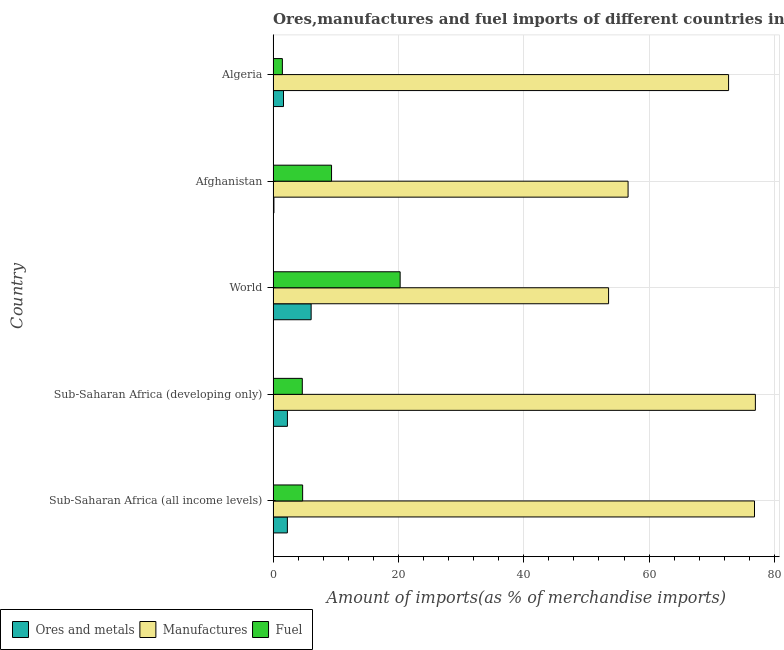How many different coloured bars are there?
Ensure brevity in your answer.  3. Are the number of bars per tick equal to the number of legend labels?
Ensure brevity in your answer.  Yes. Are the number of bars on each tick of the Y-axis equal?
Your answer should be compact. Yes. How many bars are there on the 3rd tick from the top?
Keep it short and to the point. 3. How many bars are there on the 1st tick from the bottom?
Your answer should be compact. 3. What is the label of the 2nd group of bars from the top?
Provide a succinct answer. Afghanistan. In how many cases, is the number of bars for a given country not equal to the number of legend labels?
Make the answer very short. 0. What is the percentage of ores and metals imports in Sub-Saharan Africa (developing only)?
Give a very brief answer. 2.28. Across all countries, what is the maximum percentage of ores and metals imports?
Give a very brief answer. 6.07. Across all countries, what is the minimum percentage of manufactures imports?
Provide a short and direct response. 53.54. In which country was the percentage of fuel imports minimum?
Keep it short and to the point. Algeria. What is the total percentage of manufactures imports in the graph?
Offer a very short reply. 336.67. What is the difference between the percentage of fuel imports in Sub-Saharan Africa (all income levels) and that in Sub-Saharan Africa (developing only)?
Ensure brevity in your answer.  0.05. What is the difference between the percentage of ores and metals imports in World and the percentage of fuel imports in Sub-Saharan Africa (developing only)?
Your answer should be compact. 1.41. What is the average percentage of manufactures imports per country?
Your answer should be compact. 67.33. What is the difference between the percentage of ores and metals imports and percentage of fuel imports in Sub-Saharan Africa (all income levels)?
Your response must be concise. -2.44. In how many countries, is the percentage of ores and metals imports greater than 28 %?
Give a very brief answer. 0. What is the ratio of the percentage of fuel imports in Sub-Saharan Africa (developing only) to that in World?
Your response must be concise. 0.23. Is the difference between the percentage of fuel imports in Algeria and Sub-Saharan Africa (developing only) greater than the difference between the percentage of ores and metals imports in Algeria and Sub-Saharan Africa (developing only)?
Provide a short and direct response. No. What is the difference between the highest and the second highest percentage of ores and metals imports?
Your response must be concise. 3.78. What is the difference between the highest and the lowest percentage of ores and metals imports?
Make the answer very short. 5.94. What does the 2nd bar from the top in Afghanistan represents?
Your answer should be very brief. Manufactures. What does the 1st bar from the bottom in Sub-Saharan Africa (developing only) represents?
Make the answer very short. Ores and metals. Are all the bars in the graph horizontal?
Your answer should be compact. Yes. What is the difference between two consecutive major ticks on the X-axis?
Keep it short and to the point. 20. How many legend labels are there?
Your answer should be very brief. 3. What is the title of the graph?
Offer a terse response. Ores,manufactures and fuel imports of different countries in 1974. What is the label or title of the X-axis?
Ensure brevity in your answer.  Amount of imports(as % of merchandise imports). What is the Amount of imports(as % of merchandise imports) in Ores and metals in Sub-Saharan Africa (all income levels)?
Give a very brief answer. 2.27. What is the Amount of imports(as % of merchandise imports) in Manufactures in Sub-Saharan Africa (all income levels)?
Your response must be concise. 76.83. What is the Amount of imports(as % of merchandise imports) in Fuel in Sub-Saharan Africa (all income levels)?
Make the answer very short. 4.71. What is the Amount of imports(as % of merchandise imports) in Ores and metals in Sub-Saharan Africa (developing only)?
Your response must be concise. 2.28. What is the Amount of imports(as % of merchandise imports) in Manufactures in Sub-Saharan Africa (developing only)?
Keep it short and to the point. 76.97. What is the Amount of imports(as % of merchandise imports) in Fuel in Sub-Saharan Africa (developing only)?
Provide a short and direct response. 4.66. What is the Amount of imports(as % of merchandise imports) of Ores and metals in World?
Give a very brief answer. 6.07. What is the Amount of imports(as % of merchandise imports) in Manufactures in World?
Give a very brief answer. 53.54. What is the Amount of imports(as % of merchandise imports) of Fuel in World?
Your response must be concise. 20.27. What is the Amount of imports(as % of merchandise imports) in Ores and metals in Afghanistan?
Provide a short and direct response. 0.13. What is the Amount of imports(as % of merchandise imports) in Manufactures in Afghanistan?
Make the answer very short. 56.65. What is the Amount of imports(as % of merchandise imports) in Fuel in Afghanistan?
Your response must be concise. 9.33. What is the Amount of imports(as % of merchandise imports) in Ores and metals in Algeria?
Offer a very short reply. 1.66. What is the Amount of imports(as % of merchandise imports) of Manufactures in Algeria?
Offer a very short reply. 72.69. What is the Amount of imports(as % of merchandise imports) of Fuel in Algeria?
Offer a very short reply. 1.48. Across all countries, what is the maximum Amount of imports(as % of merchandise imports) of Ores and metals?
Provide a succinct answer. 6.07. Across all countries, what is the maximum Amount of imports(as % of merchandise imports) in Manufactures?
Make the answer very short. 76.97. Across all countries, what is the maximum Amount of imports(as % of merchandise imports) of Fuel?
Your answer should be compact. 20.27. Across all countries, what is the minimum Amount of imports(as % of merchandise imports) in Ores and metals?
Your answer should be compact. 0.13. Across all countries, what is the minimum Amount of imports(as % of merchandise imports) of Manufactures?
Ensure brevity in your answer.  53.54. Across all countries, what is the minimum Amount of imports(as % of merchandise imports) in Fuel?
Offer a very short reply. 1.48. What is the total Amount of imports(as % of merchandise imports) in Ores and metals in the graph?
Provide a succinct answer. 12.41. What is the total Amount of imports(as % of merchandise imports) in Manufactures in the graph?
Provide a succinct answer. 336.67. What is the total Amount of imports(as % of merchandise imports) of Fuel in the graph?
Your answer should be compact. 40.44. What is the difference between the Amount of imports(as % of merchandise imports) of Ores and metals in Sub-Saharan Africa (all income levels) and that in Sub-Saharan Africa (developing only)?
Ensure brevity in your answer.  -0.01. What is the difference between the Amount of imports(as % of merchandise imports) in Manufactures in Sub-Saharan Africa (all income levels) and that in Sub-Saharan Africa (developing only)?
Your answer should be very brief. -0.14. What is the difference between the Amount of imports(as % of merchandise imports) of Fuel in Sub-Saharan Africa (all income levels) and that in Sub-Saharan Africa (developing only)?
Give a very brief answer. 0.05. What is the difference between the Amount of imports(as % of merchandise imports) of Ores and metals in Sub-Saharan Africa (all income levels) and that in World?
Offer a terse response. -3.79. What is the difference between the Amount of imports(as % of merchandise imports) in Manufactures in Sub-Saharan Africa (all income levels) and that in World?
Your answer should be very brief. 23.29. What is the difference between the Amount of imports(as % of merchandise imports) of Fuel in Sub-Saharan Africa (all income levels) and that in World?
Give a very brief answer. -15.56. What is the difference between the Amount of imports(as % of merchandise imports) of Ores and metals in Sub-Saharan Africa (all income levels) and that in Afghanistan?
Provide a short and direct response. 2.15. What is the difference between the Amount of imports(as % of merchandise imports) in Manufactures in Sub-Saharan Africa (all income levels) and that in Afghanistan?
Offer a very short reply. 20.18. What is the difference between the Amount of imports(as % of merchandise imports) in Fuel in Sub-Saharan Africa (all income levels) and that in Afghanistan?
Keep it short and to the point. -4.61. What is the difference between the Amount of imports(as % of merchandise imports) in Ores and metals in Sub-Saharan Africa (all income levels) and that in Algeria?
Your response must be concise. 0.62. What is the difference between the Amount of imports(as % of merchandise imports) of Manufactures in Sub-Saharan Africa (all income levels) and that in Algeria?
Provide a short and direct response. 4.14. What is the difference between the Amount of imports(as % of merchandise imports) of Fuel in Sub-Saharan Africa (all income levels) and that in Algeria?
Provide a succinct answer. 3.23. What is the difference between the Amount of imports(as % of merchandise imports) of Ores and metals in Sub-Saharan Africa (developing only) and that in World?
Your response must be concise. -3.78. What is the difference between the Amount of imports(as % of merchandise imports) of Manufactures in Sub-Saharan Africa (developing only) and that in World?
Ensure brevity in your answer.  23.43. What is the difference between the Amount of imports(as % of merchandise imports) of Fuel in Sub-Saharan Africa (developing only) and that in World?
Give a very brief answer. -15.61. What is the difference between the Amount of imports(as % of merchandise imports) of Ores and metals in Sub-Saharan Africa (developing only) and that in Afghanistan?
Keep it short and to the point. 2.16. What is the difference between the Amount of imports(as % of merchandise imports) of Manufactures in Sub-Saharan Africa (developing only) and that in Afghanistan?
Your answer should be compact. 20.32. What is the difference between the Amount of imports(as % of merchandise imports) in Fuel in Sub-Saharan Africa (developing only) and that in Afghanistan?
Keep it short and to the point. -4.67. What is the difference between the Amount of imports(as % of merchandise imports) in Ores and metals in Sub-Saharan Africa (developing only) and that in Algeria?
Provide a short and direct response. 0.63. What is the difference between the Amount of imports(as % of merchandise imports) of Manufactures in Sub-Saharan Africa (developing only) and that in Algeria?
Offer a terse response. 4.28. What is the difference between the Amount of imports(as % of merchandise imports) in Fuel in Sub-Saharan Africa (developing only) and that in Algeria?
Offer a very short reply. 3.18. What is the difference between the Amount of imports(as % of merchandise imports) in Ores and metals in World and that in Afghanistan?
Your response must be concise. 5.94. What is the difference between the Amount of imports(as % of merchandise imports) of Manufactures in World and that in Afghanistan?
Offer a very short reply. -3.11. What is the difference between the Amount of imports(as % of merchandise imports) in Fuel in World and that in Afghanistan?
Provide a short and direct response. 10.95. What is the difference between the Amount of imports(as % of merchandise imports) of Ores and metals in World and that in Algeria?
Ensure brevity in your answer.  4.41. What is the difference between the Amount of imports(as % of merchandise imports) in Manufactures in World and that in Algeria?
Provide a short and direct response. -19.15. What is the difference between the Amount of imports(as % of merchandise imports) in Fuel in World and that in Algeria?
Your answer should be compact. 18.79. What is the difference between the Amount of imports(as % of merchandise imports) in Ores and metals in Afghanistan and that in Algeria?
Offer a very short reply. -1.53. What is the difference between the Amount of imports(as % of merchandise imports) of Manufactures in Afghanistan and that in Algeria?
Provide a short and direct response. -16.04. What is the difference between the Amount of imports(as % of merchandise imports) of Fuel in Afghanistan and that in Algeria?
Provide a short and direct response. 7.85. What is the difference between the Amount of imports(as % of merchandise imports) in Ores and metals in Sub-Saharan Africa (all income levels) and the Amount of imports(as % of merchandise imports) in Manufactures in Sub-Saharan Africa (developing only)?
Your answer should be compact. -74.69. What is the difference between the Amount of imports(as % of merchandise imports) of Ores and metals in Sub-Saharan Africa (all income levels) and the Amount of imports(as % of merchandise imports) of Fuel in Sub-Saharan Africa (developing only)?
Ensure brevity in your answer.  -2.38. What is the difference between the Amount of imports(as % of merchandise imports) in Manufactures in Sub-Saharan Africa (all income levels) and the Amount of imports(as % of merchandise imports) in Fuel in Sub-Saharan Africa (developing only)?
Your answer should be very brief. 72.17. What is the difference between the Amount of imports(as % of merchandise imports) of Ores and metals in Sub-Saharan Africa (all income levels) and the Amount of imports(as % of merchandise imports) of Manufactures in World?
Give a very brief answer. -51.26. What is the difference between the Amount of imports(as % of merchandise imports) of Ores and metals in Sub-Saharan Africa (all income levels) and the Amount of imports(as % of merchandise imports) of Fuel in World?
Keep it short and to the point. -18. What is the difference between the Amount of imports(as % of merchandise imports) of Manufactures in Sub-Saharan Africa (all income levels) and the Amount of imports(as % of merchandise imports) of Fuel in World?
Offer a very short reply. 56.56. What is the difference between the Amount of imports(as % of merchandise imports) of Ores and metals in Sub-Saharan Africa (all income levels) and the Amount of imports(as % of merchandise imports) of Manufactures in Afghanistan?
Your response must be concise. -54.38. What is the difference between the Amount of imports(as % of merchandise imports) in Ores and metals in Sub-Saharan Africa (all income levels) and the Amount of imports(as % of merchandise imports) in Fuel in Afghanistan?
Your response must be concise. -7.05. What is the difference between the Amount of imports(as % of merchandise imports) in Manufactures in Sub-Saharan Africa (all income levels) and the Amount of imports(as % of merchandise imports) in Fuel in Afghanistan?
Make the answer very short. 67.5. What is the difference between the Amount of imports(as % of merchandise imports) of Ores and metals in Sub-Saharan Africa (all income levels) and the Amount of imports(as % of merchandise imports) of Manufactures in Algeria?
Your response must be concise. -70.42. What is the difference between the Amount of imports(as % of merchandise imports) of Ores and metals in Sub-Saharan Africa (all income levels) and the Amount of imports(as % of merchandise imports) of Fuel in Algeria?
Ensure brevity in your answer.  0.8. What is the difference between the Amount of imports(as % of merchandise imports) in Manufactures in Sub-Saharan Africa (all income levels) and the Amount of imports(as % of merchandise imports) in Fuel in Algeria?
Your answer should be compact. 75.35. What is the difference between the Amount of imports(as % of merchandise imports) of Ores and metals in Sub-Saharan Africa (developing only) and the Amount of imports(as % of merchandise imports) of Manufactures in World?
Your response must be concise. -51.25. What is the difference between the Amount of imports(as % of merchandise imports) of Ores and metals in Sub-Saharan Africa (developing only) and the Amount of imports(as % of merchandise imports) of Fuel in World?
Make the answer very short. -17.99. What is the difference between the Amount of imports(as % of merchandise imports) in Manufactures in Sub-Saharan Africa (developing only) and the Amount of imports(as % of merchandise imports) in Fuel in World?
Give a very brief answer. 56.7. What is the difference between the Amount of imports(as % of merchandise imports) in Ores and metals in Sub-Saharan Africa (developing only) and the Amount of imports(as % of merchandise imports) in Manufactures in Afghanistan?
Give a very brief answer. -54.37. What is the difference between the Amount of imports(as % of merchandise imports) in Ores and metals in Sub-Saharan Africa (developing only) and the Amount of imports(as % of merchandise imports) in Fuel in Afghanistan?
Provide a succinct answer. -7.04. What is the difference between the Amount of imports(as % of merchandise imports) of Manufactures in Sub-Saharan Africa (developing only) and the Amount of imports(as % of merchandise imports) of Fuel in Afghanistan?
Your response must be concise. 67.64. What is the difference between the Amount of imports(as % of merchandise imports) of Ores and metals in Sub-Saharan Africa (developing only) and the Amount of imports(as % of merchandise imports) of Manufactures in Algeria?
Keep it short and to the point. -70.41. What is the difference between the Amount of imports(as % of merchandise imports) in Ores and metals in Sub-Saharan Africa (developing only) and the Amount of imports(as % of merchandise imports) in Fuel in Algeria?
Your response must be concise. 0.81. What is the difference between the Amount of imports(as % of merchandise imports) in Manufactures in Sub-Saharan Africa (developing only) and the Amount of imports(as % of merchandise imports) in Fuel in Algeria?
Offer a very short reply. 75.49. What is the difference between the Amount of imports(as % of merchandise imports) in Ores and metals in World and the Amount of imports(as % of merchandise imports) in Manufactures in Afghanistan?
Keep it short and to the point. -50.58. What is the difference between the Amount of imports(as % of merchandise imports) in Ores and metals in World and the Amount of imports(as % of merchandise imports) in Fuel in Afghanistan?
Give a very brief answer. -3.26. What is the difference between the Amount of imports(as % of merchandise imports) of Manufactures in World and the Amount of imports(as % of merchandise imports) of Fuel in Afghanistan?
Make the answer very short. 44.21. What is the difference between the Amount of imports(as % of merchandise imports) of Ores and metals in World and the Amount of imports(as % of merchandise imports) of Manufactures in Algeria?
Ensure brevity in your answer.  -66.62. What is the difference between the Amount of imports(as % of merchandise imports) of Ores and metals in World and the Amount of imports(as % of merchandise imports) of Fuel in Algeria?
Give a very brief answer. 4.59. What is the difference between the Amount of imports(as % of merchandise imports) of Manufactures in World and the Amount of imports(as % of merchandise imports) of Fuel in Algeria?
Give a very brief answer. 52.06. What is the difference between the Amount of imports(as % of merchandise imports) in Ores and metals in Afghanistan and the Amount of imports(as % of merchandise imports) in Manufactures in Algeria?
Your answer should be compact. -72.56. What is the difference between the Amount of imports(as % of merchandise imports) of Ores and metals in Afghanistan and the Amount of imports(as % of merchandise imports) of Fuel in Algeria?
Your answer should be compact. -1.35. What is the difference between the Amount of imports(as % of merchandise imports) of Manufactures in Afghanistan and the Amount of imports(as % of merchandise imports) of Fuel in Algeria?
Make the answer very short. 55.17. What is the average Amount of imports(as % of merchandise imports) in Ores and metals per country?
Your answer should be very brief. 2.48. What is the average Amount of imports(as % of merchandise imports) in Manufactures per country?
Provide a short and direct response. 67.33. What is the average Amount of imports(as % of merchandise imports) in Fuel per country?
Give a very brief answer. 8.09. What is the difference between the Amount of imports(as % of merchandise imports) in Ores and metals and Amount of imports(as % of merchandise imports) in Manufactures in Sub-Saharan Africa (all income levels)?
Keep it short and to the point. -74.55. What is the difference between the Amount of imports(as % of merchandise imports) of Ores and metals and Amount of imports(as % of merchandise imports) of Fuel in Sub-Saharan Africa (all income levels)?
Make the answer very short. -2.44. What is the difference between the Amount of imports(as % of merchandise imports) in Manufactures and Amount of imports(as % of merchandise imports) in Fuel in Sub-Saharan Africa (all income levels)?
Keep it short and to the point. 72.12. What is the difference between the Amount of imports(as % of merchandise imports) of Ores and metals and Amount of imports(as % of merchandise imports) of Manufactures in Sub-Saharan Africa (developing only)?
Give a very brief answer. -74.68. What is the difference between the Amount of imports(as % of merchandise imports) of Ores and metals and Amount of imports(as % of merchandise imports) of Fuel in Sub-Saharan Africa (developing only)?
Ensure brevity in your answer.  -2.37. What is the difference between the Amount of imports(as % of merchandise imports) of Manufactures and Amount of imports(as % of merchandise imports) of Fuel in Sub-Saharan Africa (developing only)?
Offer a very short reply. 72.31. What is the difference between the Amount of imports(as % of merchandise imports) in Ores and metals and Amount of imports(as % of merchandise imports) in Manufactures in World?
Make the answer very short. -47.47. What is the difference between the Amount of imports(as % of merchandise imports) of Ores and metals and Amount of imports(as % of merchandise imports) of Fuel in World?
Offer a very short reply. -14.2. What is the difference between the Amount of imports(as % of merchandise imports) in Manufactures and Amount of imports(as % of merchandise imports) in Fuel in World?
Ensure brevity in your answer.  33.27. What is the difference between the Amount of imports(as % of merchandise imports) in Ores and metals and Amount of imports(as % of merchandise imports) in Manufactures in Afghanistan?
Your response must be concise. -56.52. What is the difference between the Amount of imports(as % of merchandise imports) in Ores and metals and Amount of imports(as % of merchandise imports) in Fuel in Afghanistan?
Keep it short and to the point. -9.2. What is the difference between the Amount of imports(as % of merchandise imports) of Manufactures and Amount of imports(as % of merchandise imports) of Fuel in Afghanistan?
Make the answer very short. 47.32. What is the difference between the Amount of imports(as % of merchandise imports) of Ores and metals and Amount of imports(as % of merchandise imports) of Manufactures in Algeria?
Give a very brief answer. -71.03. What is the difference between the Amount of imports(as % of merchandise imports) of Ores and metals and Amount of imports(as % of merchandise imports) of Fuel in Algeria?
Keep it short and to the point. 0.18. What is the difference between the Amount of imports(as % of merchandise imports) of Manufactures and Amount of imports(as % of merchandise imports) of Fuel in Algeria?
Your response must be concise. 71.21. What is the ratio of the Amount of imports(as % of merchandise imports) of Ores and metals in Sub-Saharan Africa (all income levels) to that in Sub-Saharan Africa (developing only)?
Your answer should be compact. 1. What is the ratio of the Amount of imports(as % of merchandise imports) of Fuel in Sub-Saharan Africa (all income levels) to that in Sub-Saharan Africa (developing only)?
Provide a short and direct response. 1.01. What is the ratio of the Amount of imports(as % of merchandise imports) of Ores and metals in Sub-Saharan Africa (all income levels) to that in World?
Give a very brief answer. 0.37. What is the ratio of the Amount of imports(as % of merchandise imports) of Manufactures in Sub-Saharan Africa (all income levels) to that in World?
Your answer should be very brief. 1.44. What is the ratio of the Amount of imports(as % of merchandise imports) of Fuel in Sub-Saharan Africa (all income levels) to that in World?
Ensure brevity in your answer.  0.23. What is the ratio of the Amount of imports(as % of merchandise imports) of Ores and metals in Sub-Saharan Africa (all income levels) to that in Afghanistan?
Provide a short and direct response. 17.95. What is the ratio of the Amount of imports(as % of merchandise imports) in Manufactures in Sub-Saharan Africa (all income levels) to that in Afghanistan?
Your response must be concise. 1.36. What is the ratio of the Amount of imports(as % of merchandise imports) of Fuel in Sub-Saharan Africa (all income levels) to that in Afghanistan?
Your answer should be compact. 0.51. What is the ratio of the Amount of imports(as % of merchandise imports) of Ores and metals in Sub-Saharan Africa (all income levels) to that in Algeria?
Make the answer very short. 1.37. What is the ratio of the Amount of imports(as % of merchandise imports) in Manufactures in Sub-Saharan Africa (all income levels) to that in Algeria?
Provide a short and direct response. 1.06. What is the ratio of the Amount of imports(as % of merchandise imports) of Fuel in Sub-Saharan Africa (all income levels) to that in Algeria?
Offer a terse response. 3.19. What is the ratio of the Amount of imports(as % of merchandise imports) of Ores and metals in Sub-Saharan Africa (developing only) to that in World?
Your answer should be compact. 0.38. What is the ratio of the Amount of imports(as % of merchandise imports) of Manufactures in Sub-Saharan Africa (developing only) to that in World?
Provide a succinct answer. 1.44. What is the ratio of the Amount of imports(as % of merchandise imports) in Fuel in Sub-Saharan Africa (developing only) to that in World?
Provide a short and direct response. 0.23. What is the ratio of the Amount of imports(as % of merchandise imports) of Ores and metals in Sub-Saharan Africa (developing only) to that in Afghanistan?
Keep it short and to the point. 18.02. What is the ratio of the Amount of imports(as % of merchandise imports) in Manufactures in Sub-Saharan Africa (developing only) to that in Afghanistan?
Keep it short and to the point. 1.36. What is the ratio of the Amount of imports(as % of merchandise imports) in Fuel in Sub-Saharan Africa (developing only) to that in Afghanistan?
Provide a short and direct response. 0.5. What is the ratio of the Amount of imports(as % of merchandise imports) in Ores and metals in Sub-Saharan Africa (developing only) to that in Algeria?
Offer a very short reply. 1.38. What is the ratio of the Amount of imports(as % of merchandise imports) of Manufactures in Sub-Saharan Africa (developing only) to that in Algeria?
Provide a short and direct response. 1.06. What is the ratio of the Amount of imports(as % of merchandise imports) of Fuel in Sub-Saharan Africa (developing only) to that in Algeria?
Provide a short and direct response. 3.15. What is the ratio of the Amount of imports(as % of merchandise imports) in Ores and metals in World to that in Afghanistan?
Your answer should be compact. 47.89. What is the ratio of the Amount of imports(as % of merchandise imports) in Manufactures in World to that in Afghanistan?
Your answer should be very brief. 0.95. What is the ratio of the Amount of imports(as % of merchandise imports) of Fuel in World to that in Afghanistan?
Offer a very short reply. 2.17. What is the ratio of the Amount of imports(as % of merchandise imports) of Ores and metals in World to that in Algeria?
Your response must be concise. 3.66. What is the ratio of the Amount of imports(as % of merchandise imports) of Manufactures in World to that in Algeria?
Provide a succinct answer. 0.74. What is the ratio of the Amount of imports(as % of merchandise imports) in Fuel in World to that in Algeria?
Make the answer very short. 13.72. What is the ratio of the Amount of imports(as % of merchandise imports) of Ores and metals in Afghanistan to that in Algeria?
Provide a short and direct response. 0.08. What is the ratio of the Amount of imports(as % of merchandise imports) in Manufactures in Afghanistan to that in Algeria?
Provide a short and direct response. 0.78. What is the ratio of the Amount of imports(as % of merchandise imports) in Fuel in Afghanistan to that in Algeria?
Offer a very short reply. 6.31. What is the difference between the highest and the second highest Amount of imports(as % of merchandise imports) in Ores and metals?
Make the answer very short. 3.78. What is the difference between the highest and the second highest Amount of imports(as % of merchandise imports) in Manufactures?
Make the answer very short. 0.14. What is the difference between the highest and the second highest Amount of imports(as % of merchandise imports) of Fuel?
Make the answer very short. 10.95. What is the difference between the highest and the lowest Amount of imports(as % of merchandise imports) of Ores and metals?
Your response must be concise. 5.94. What is the difference between the highest and the lowest Amount of imports(as % of merchandise imports) of Manufactures?
Keep it short and to the point. 23.43. What is the difference between the highest and the lowest Amount of imports(as % of merchandise imports) in Fuel?
Provide a succinct answer. 18.79. 